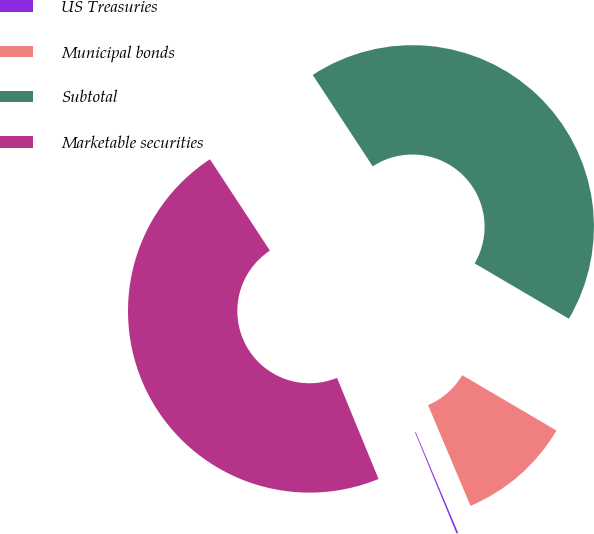Convert chart to OTSL. <chart><loc_0><loc_0><loc_500><loc_500><pie_chart><fcel>US Treasuries<fcel>Municipal bonds<fcel>Subtotal<fcel>Marketable securities<nl><fcel>0.15%<fcel>10.19%<fcel>42.7%<fcel>46.96%<nl></chart> 